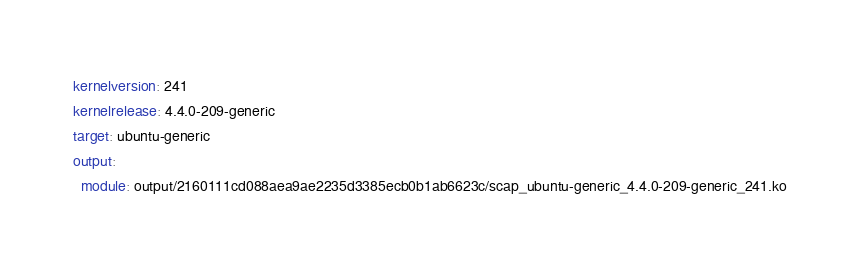<code> <loc_0><loc_0><loc_500><loc_500><_YAML_>kernelversion: 241
kernelrelease: 4.4.0-209-generic
target: ubuntu-generic
output:
  module: output/2160111cd088aea9ae2235d3385ecb0b1ab6623c/scap_ubuntu-generic_4.4.0-209-generic_241.ko
</code> 